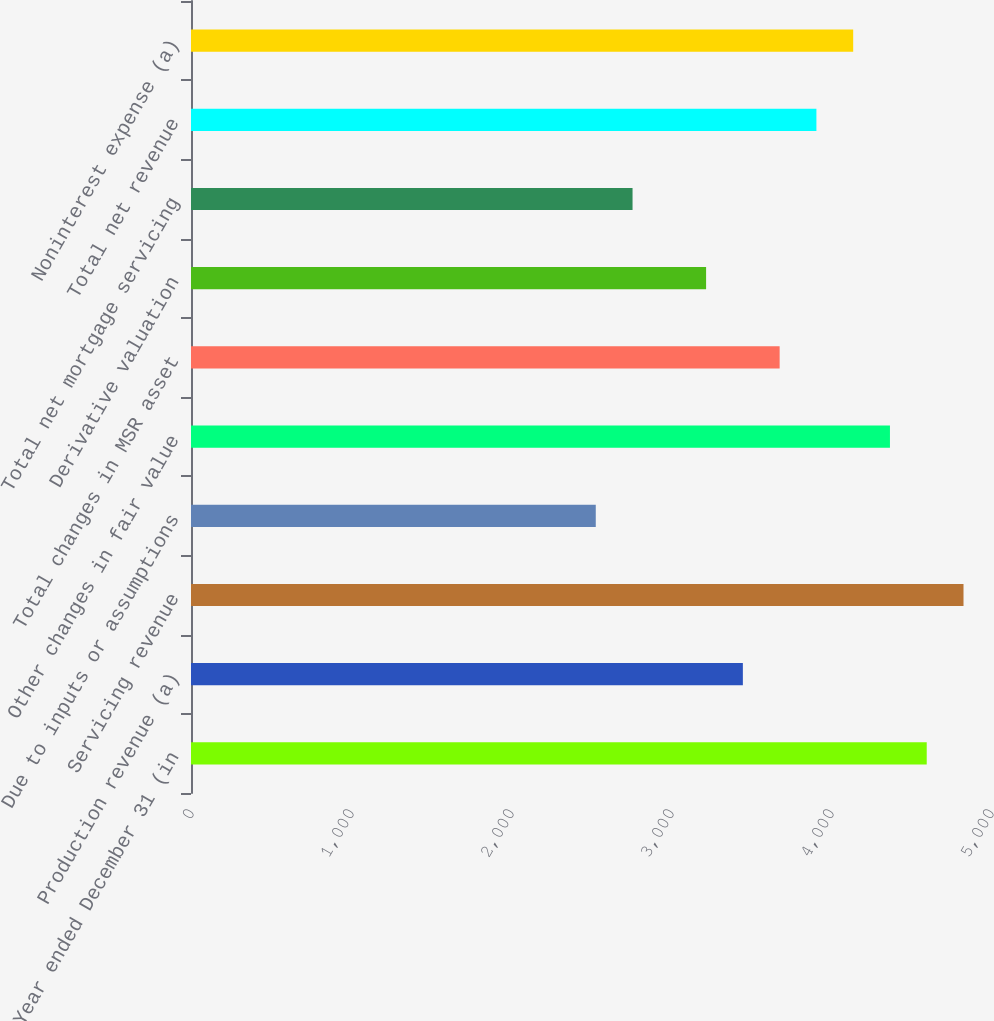Convert chart to OTSL. <chart><loc_0><loc_0><loc_500><loc_500><bar_chart><fcel>Year ended December 31 (in<fcel>Production revenue (a)<fcel>Servicing revenue<fcel>Due to inputs or assumptions<fcel>Other changes in fair value<fcel>Total changes in MSR asset<fcel>Derivative valuation<fcel>Total net mortgage servicing<fcel>Total net revenue<fcel>Noninterest expense (a)<nl><fcel>4598.3<fcel>3449.15<fcel>4828.13<fcel>2529.83<fcel>4368.47<fcel>3678.98<fcel>3219.32<fcel>2759.66<fcel>3908.81<fcel>4138.64<nl></chart> 